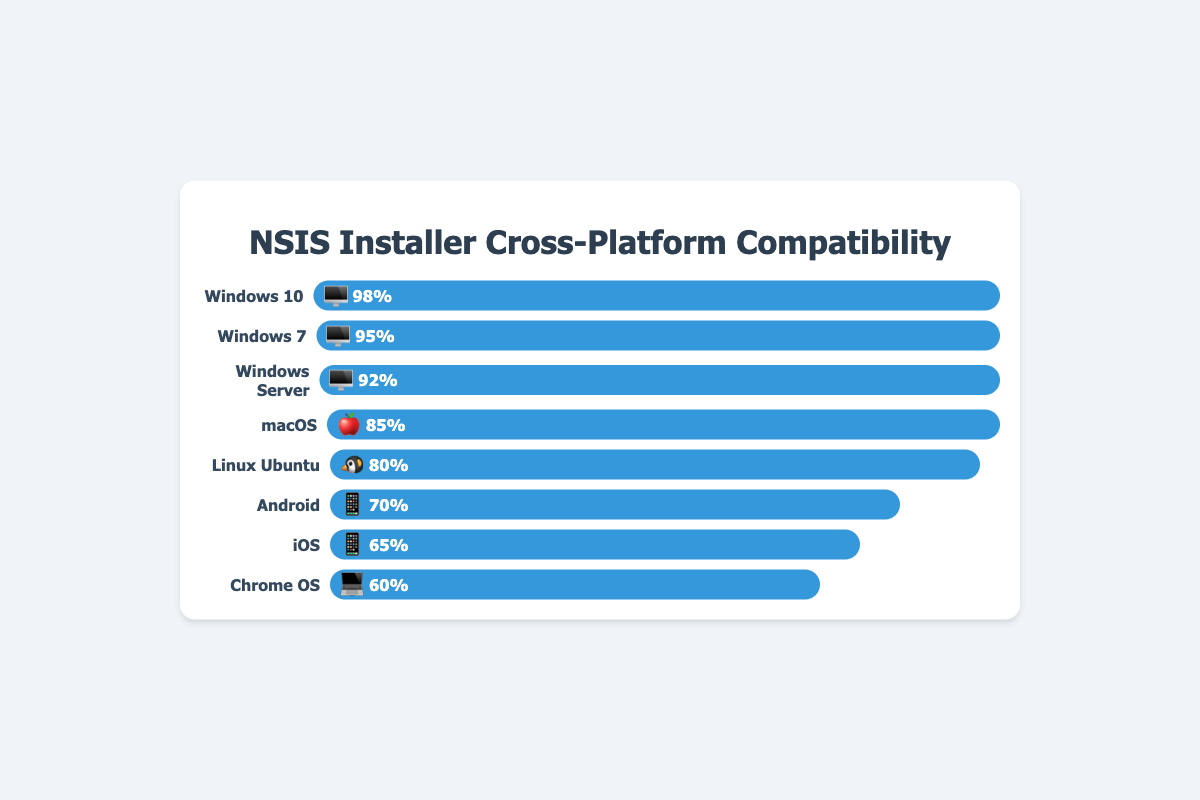What is the success rate for Windows 10 🖥️? Look at the bar labeled "Windows 10" with the 🖥️ emoji. The width of the bar and the text inside it show a success rate of 98%.
Answer: 98% Which platform has the lowest success rate? Identify the bar with the shortest width and lowest percentage. The "Chrome OS" 💻 bar has the lowest success rate of 60%.
Answer: Chrome OS (60%) How many platforms have a success rate above 90%? Count the number of bars with a success rate exceeding 90%. "Windows 10" 🖥️, "Windows 7" 🖥️, and "Windows Server" 🖥️ all have rates above 90%.
Answer: 3 Which operating system has a higher success rate, Android 📱 or iOS 📱? Compare the success rates of the bars labeled "Android" and "iOS." Android 📱 has a 70% success rate, while iOS 📱 has a 65% success rate.
Answer: Android (70%) What is the difference in success rates between macOS 🍎 and Linux Ubuntu 🐧? Subtract the success rate of Linux Ubuntu 🐧 from that of macOS 🍎. macOS (85%) - Linux Ubuntu (80%) = 5%.
Answer: 5% Which platform has the third highest success rate? Arrange the bars in descending order and find the third one. The top three are Windows 10 🖥️ (98%), Windows 7 🖥️ (95%), and macOS 🍎 (85%).
Answer: macOS (85%) What's the average success rate for all listed platforms? Sum the success rates and divide by the number of platforms: (98% + 95% + 85% + 80% + 70% + 65% + 60% + 92%) / 8 = 80.625%.
Answer: 80.625% Which has a higher success rate on average, desktop platforms or mobile platforms? Average the success rates for desktop (Windows 10, Windows 7, macOS, Linux Ubuntu, Chrome OS, Windows Server) and mobile (Android, iOS). Desktop average: (98% + 95% + 85% + 80% + 60% + 92%) / 6 = 85%. Mobile average: (70% + 65%) / 2 = 67.5%.
Answer: Desktop (85%) 